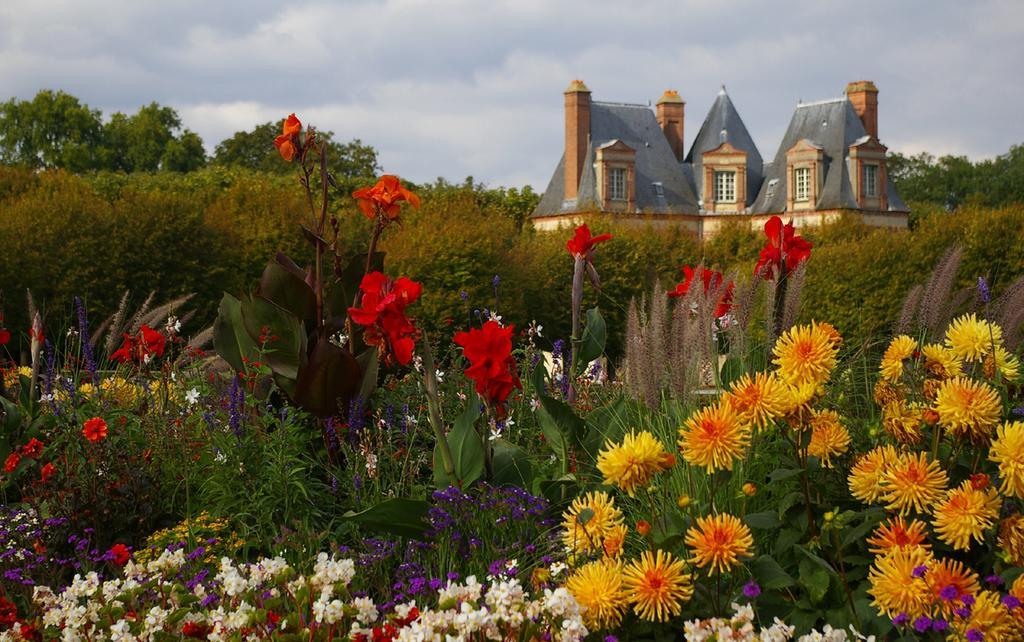Can you describe this image briefly? In this image there are plants. There are flowers to the plants. Behind them there is a house. In the background there are trees. At the top there is the sky. 